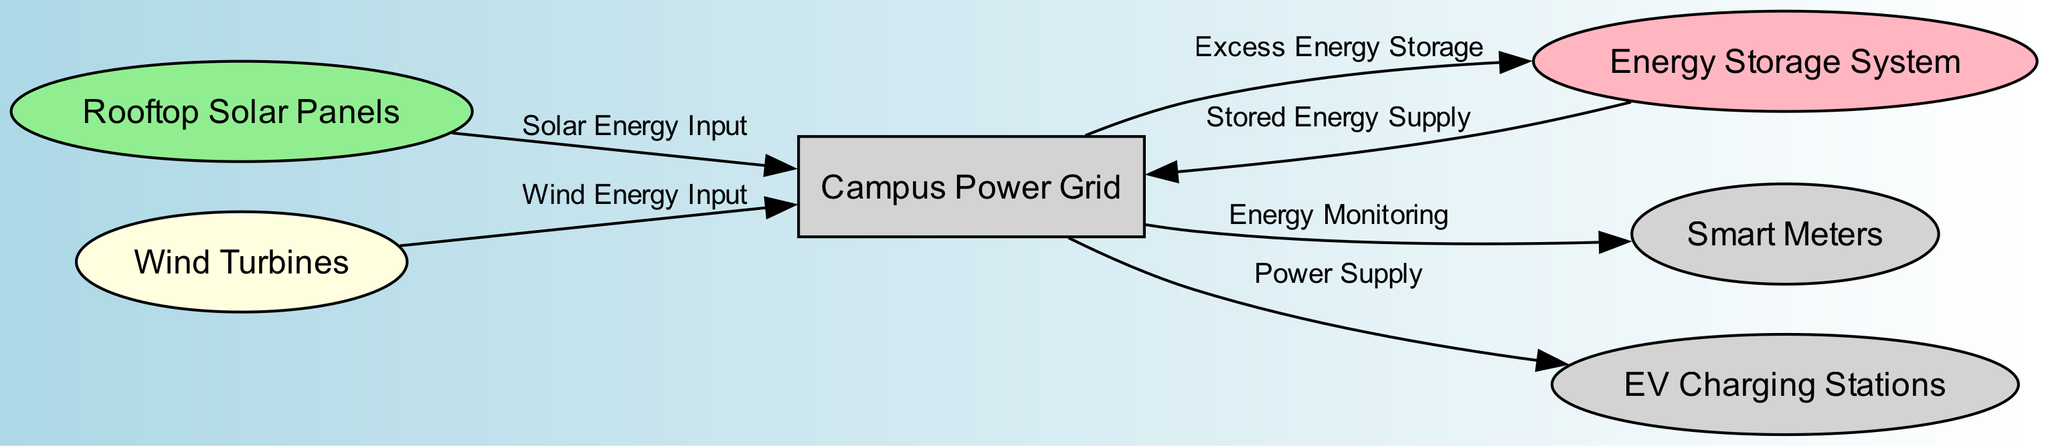What is the main component in the diagram? The main component is represented by the "Campus Power Grid". It acts as the central node connected to other inputs and outputs for energy management.
Answer: Campus Power Grid How many nodes are present in the diagram? By counting each unique node listed, there are six nodes: Campus Power Grid, Rooftop Solar Panels, Wind Turbines, Energy Storage System, Smart Meters, and EV Charging Stations.
Answer: 6 What type of energy do the wind turbines provide? The wind turbines provide "Wind Energy Input" to the campus power grid, as indicated in the directed edge leading towards it.
Answer: Wind Energy Input Which system receives excess energy storage from the campus grid? The "Energy Storage System" receives excess energy storage from the campus grid, as shown by the directed edge that points from the campus grid to the energy storage node.
Answer: Energy Storage System What is the relationship between the solar panels and the campus grid? The relationship is described as "Solar Energy Input", meaning the solar panels supply energy directly to the campus grid.
Answer: Solar Energy Input What do smart meters monitor? Smart meters are involved in "Energy Monitoring" from the campus grid, meaning they track and measure the energy flow supplied to them.
Answer: Energy Monitoring How does the campus grid interact with EV charging stations? The campus grid supplies power to the EV charging stations, as indicated by the directed edge from the campus grid to the EV charging station node.
Answer: Power Supply What is the role of the battery storage system in this diagram? The battery storage system has dual roles, supplying stored energy to the campus grid and also receiving excess energy storage from the grid, making it an important part of energy management.
Answer: Dual roles Which node is connected to three different edges? The "Campus Power Grid" connects to three edges: one from the solar panels, one from the wind turbines, and one going to the smart meters, indicating multiple inputs and outputs.
Answer: Campus Power Grid 